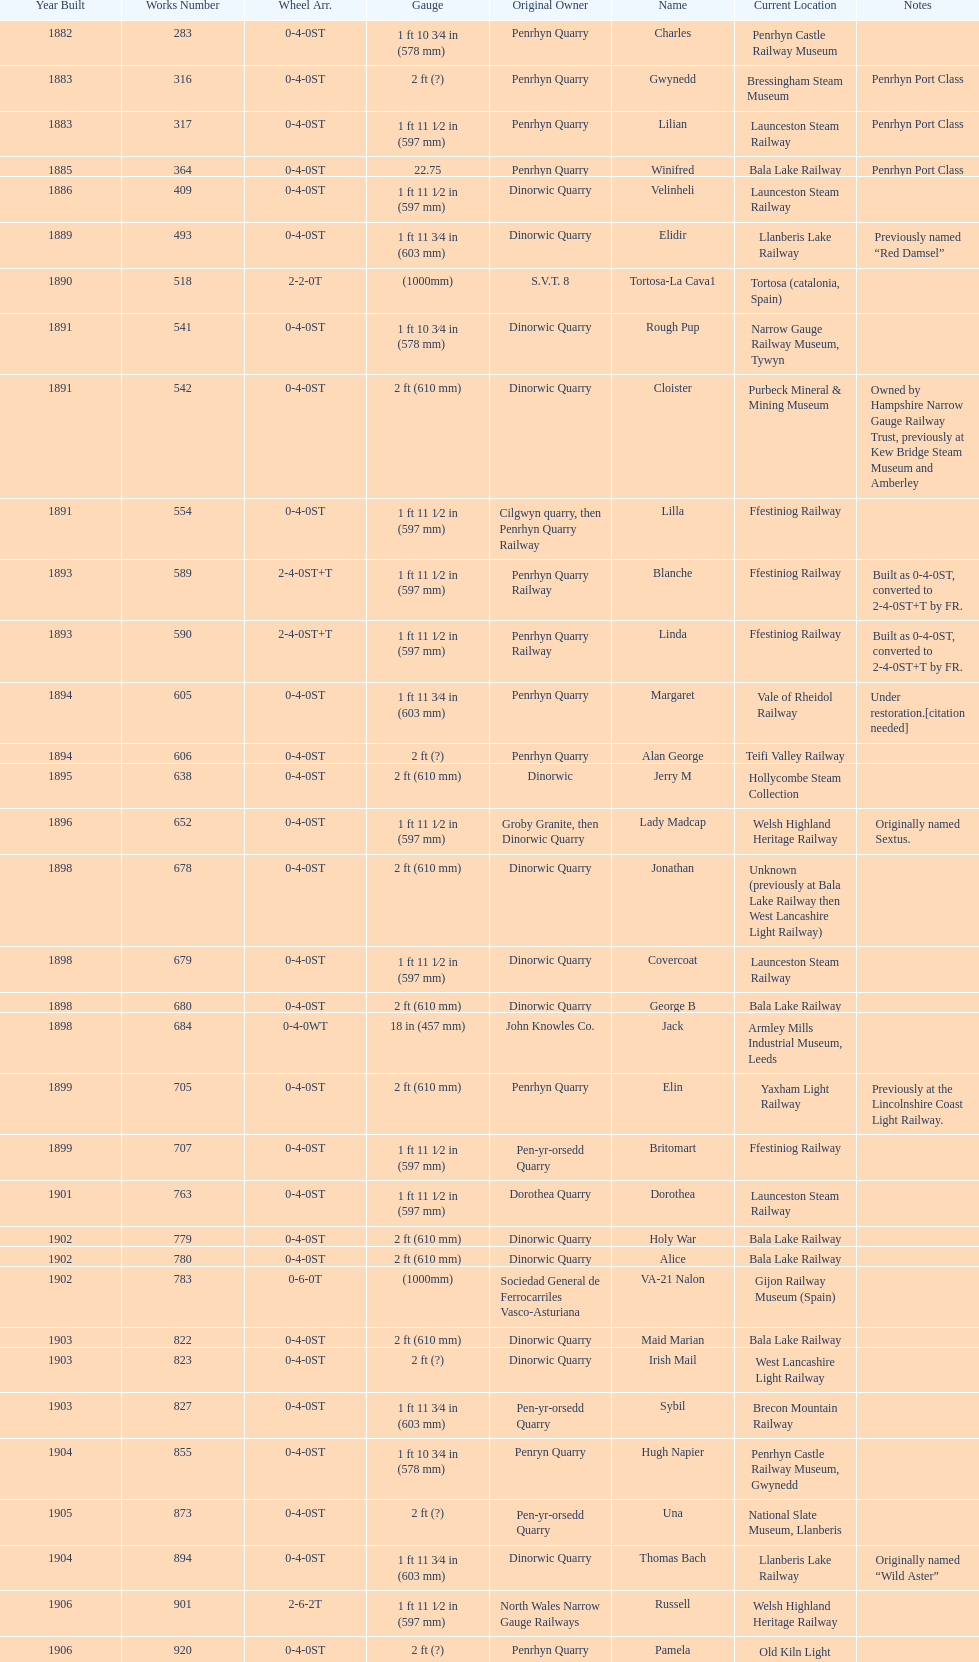How many steam locomotives are currently located at the bala lake railway? 364. 